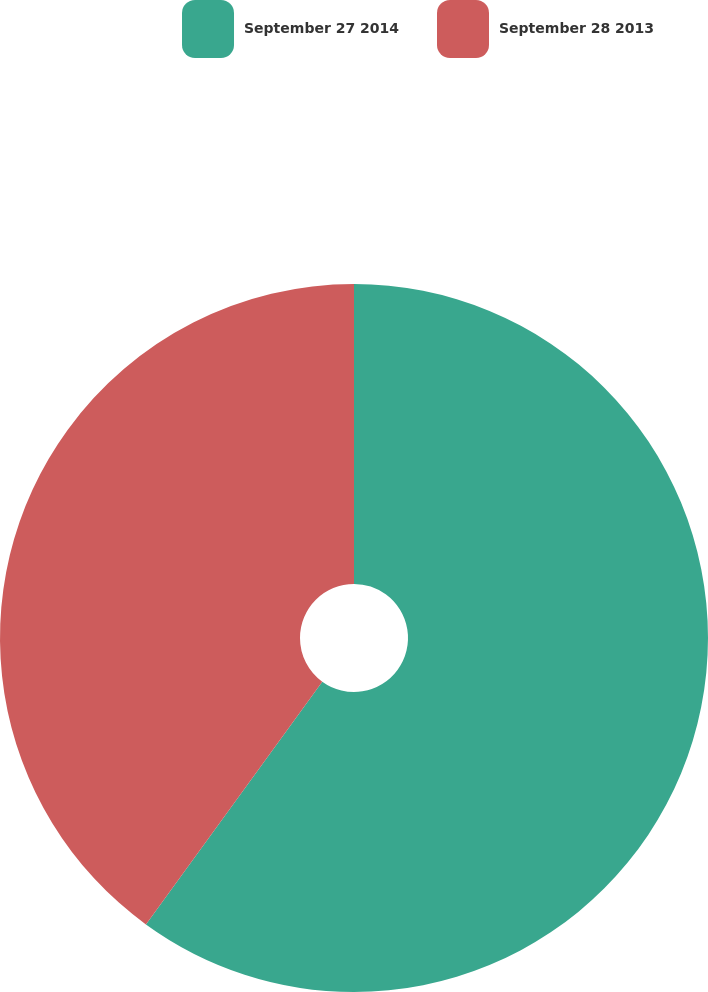Convert chart. <chart><loc_0><loc_0><loc_500><loc_500><pie_chart><fcel>September 27 2014<fcel>September 28 2013<nl><fcel>60.0%<fcel>40.0%<nl></chart> 